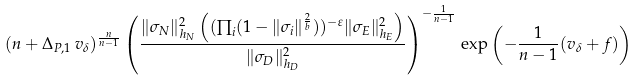<formula> <loc_0><loc_0><loc_500><loc_500>( n + \Delta _ { P , 1 } \, v _ { \delta } ) ^ { \frac { n } { n - 1 } } \left ( \frac { \| \sigma _ { N } \| _ { h _ { N } } ^ { 2 } \left ( ( \prod _ { i } ( 1 - \| \sigma _ { i } \| ^ { \frac { 2 } { b } } ) ) ^ { - \varepsilon } \| \sigma _ { E } \| _ { h _ { E } } ^ { 2 } \right ) } { \| \sigma _ { D } \| ^ { 2 } _ { h _ { D } } } \right ) ^ { - \frac { 1 } { n - 1 } } \, \exp \left ( - \frac { 1 } { n - 1 } ( v _ { \delta } + f ) \right )</formula> 